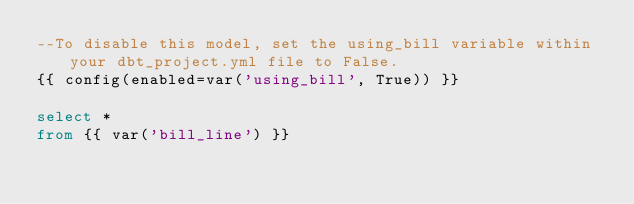Convert code to text. <code><loc_0><loc_0><loc_500><loc_500><_SQL_>--To disable this model, set the using_bill variable within your dbt_project.yml file to False.
{{ config(enabled=var('using_bill', True)) }}

select * 
from {{ var('bill_line') }}
</code> 